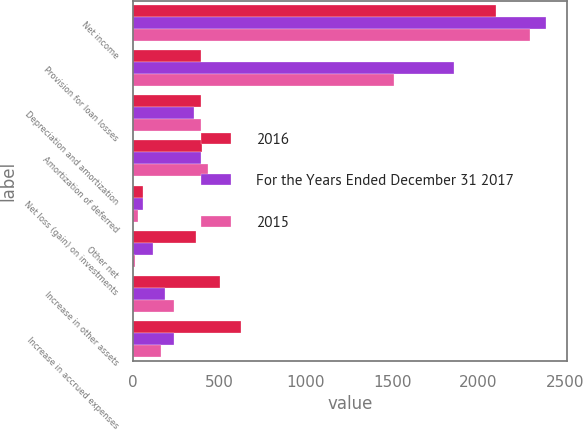<chart> <loc_0><loc_0><loc_500><loc_500><stacked_bar_chart><ecel><fcel>Net income<fcel>Provision for loan losses<fcel>Depreciation and amortization<fcel>Amortization of deferred<fcel>Net loss (gain) on investments<fcel>Other net<fcel>Increase in other assets<fcel>Increase in accrued expenses<nl><fcel>2016<fcel>2099<fcel>391<fcel>393<fcel>399<fcel>55<fcel>361<fcel>502<fcel>622<nl><fcel>For the Years Ended December 31 2017<fcel>2393<fcel>1859<fcel>351<fcel>395<fcel>57<fcel>113<fcel>187<fcel>234<nl><fcel>2015<fcel>2297<fcel>1512<fcel>391<fcel>432<fcel>26<fcel>8<fcel>237<fcel>162<nl></chart> 